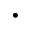<formula> <loc_0><loc_0><loc_500><loc_500>\cdot</formula> 